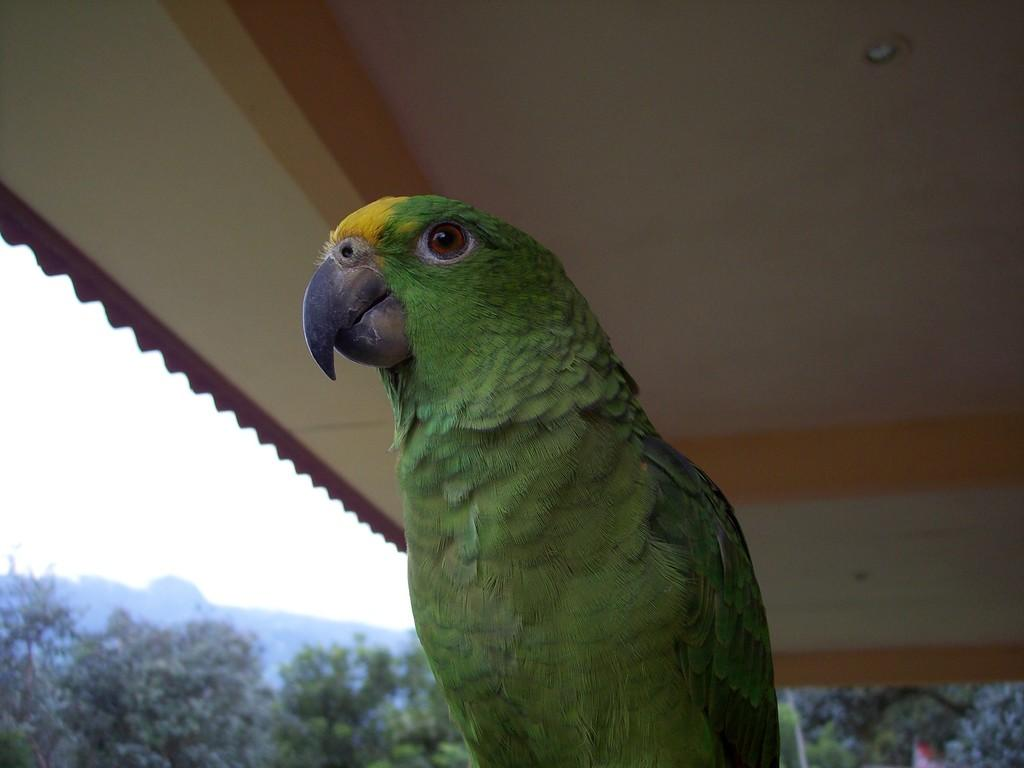What type of animal is in the image? There is a parrot in the image. What is above the parrot in the image? There is a ceiling visible in the image. What type of vegetation is in the image? There are trees in the image. What part of the sky is visible in the image? The sky is visible on the left side of the image. What is the name of the kettle in the image? There is no kettle present in the image. How does the parrot slip on the tree branch in the image? The parrot does not slip on a tree branch in the image; it is perched on a branch. 